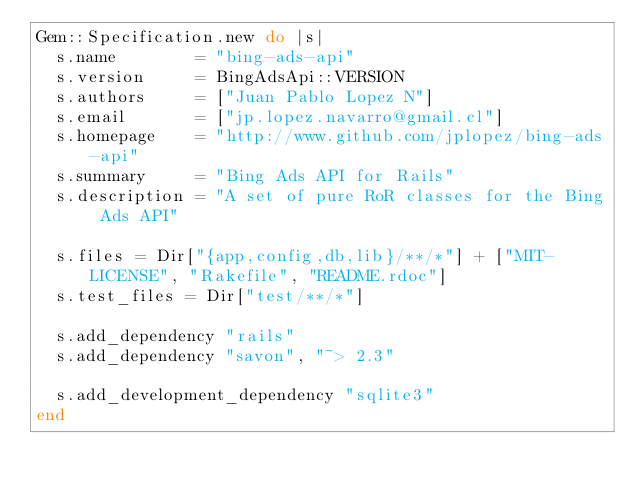Convert code to text. <code><loc_0><loc_0><loc_500><loc_500><_Ruby_>Gem::Specification.new do |s|
	s.name        = "bing-ads-api"
	s.version     = BingAdsApi::VERSION
	s.authors     = ["Juan Pablo Lopez N"]
	s.email       = ["jp.lopez.navarro@gmail.cl"]
	s.homepage    = "http://www.github.com/jplopez/bing-ads-api"
	s.summary     = "Bing Ads API for Rails"
	s.description = "A set of pure RoR classes for the Bing Ads API"

	s.files = Dir["{app,config,db,lib}/**/*"] + ["MIT-LICENSE", "Rakefile", "README.rdoc"]
	s.test_files = Dir["test/**/*"]

	s.add_dependency "rails"
	s.add_dependency "savon", "~> 2.3"

	s.add_development_dependency "sqlite3"
end
</code> 